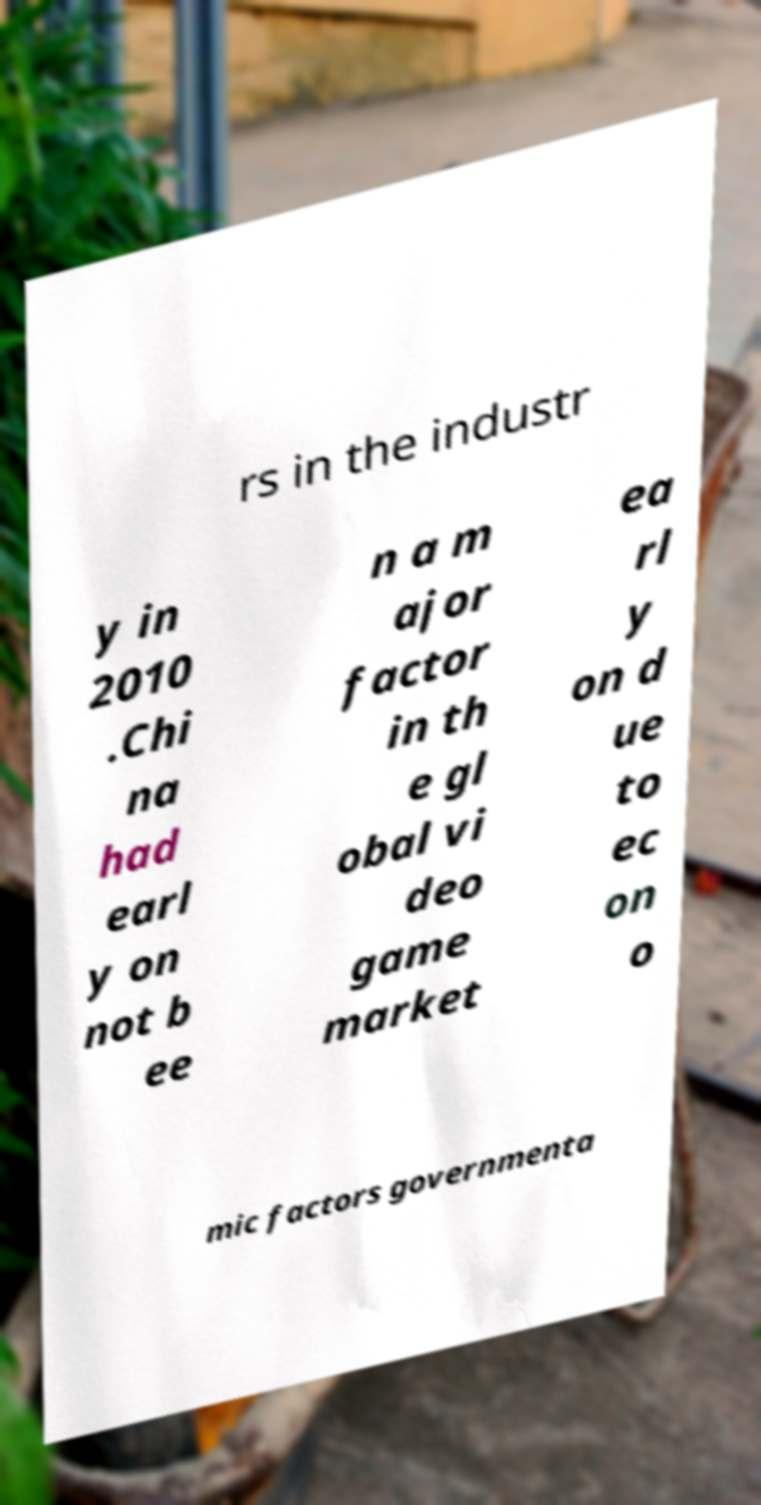Please identify and transcribe the text found in this image. rs in the industr y in 2010 .Chi na had earl y on not b ee n a m ajor factor in th e gl obal vi deo game market ea rl y on d ue to ec on o mic factors governmenta 